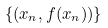<formula> <loc_0><loc_0><loc_500><loc_500>\{ ( x _ { n } , f ( x _ { n } ) ) \}</formula> 